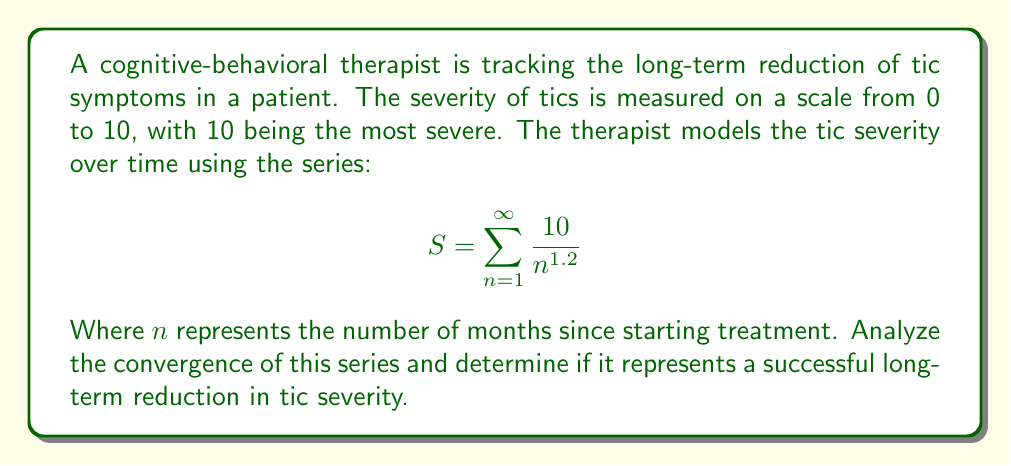Help me with this question. To analyze the convergence of this series, we can use the p-series test:

1) The general form of a p-series is $\sum_{n=1}^{\infty} \frac{1}{n^p}$

2) Our series can be rewritten as $10 \sum_{n=1}^{\infty} \frac{1}{n^{1.2}}$

3) The constant 10 doesn't affect convergence, so we focus on $\sum_{n=1}^{\infty} \frac{1}{n^{1.2}}$

4) For a p-series:
   - If $p > 1$, the series converges
   - If $p \leq 1$, the series diverges

5) In our case, $p = 1.2$

6) Since $1.2 > 1$, the series converges

7) The convergence of the series implies that the sum approaches a finite value as $n$ approaches infinity

8) In the context of tic severity:
   - The series starting at 10 (maximum severity) and converging to a finite sum less than 10 represents a reduction in tic severity over time
   - The decreasing terms of the series $\frac{10}{n^{1.2}}$ show that the severity decreases more rapidly at first and then more slowly over time

Therefore, the convergence of this series represents a successful long-term reduction in tic severity, with the patient's symptoms improving over time and stabilizing at a lower level.
Answer: The series converges, representing a successful long-term reduction in tic severity. 